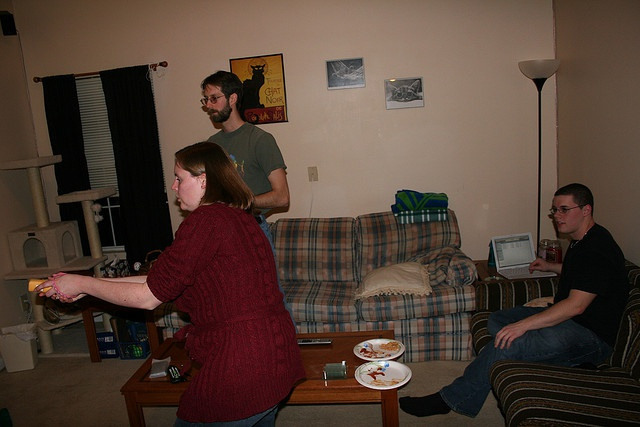Describe the objects in this image and their specific colors. I can see people in black, maroon, brown, and salmon tones, couch in black, gray, and maroon tones, people in black, maroon, and brown tones, couch in black and gray tones, and people in black, maroon, and brown tones in this image. 